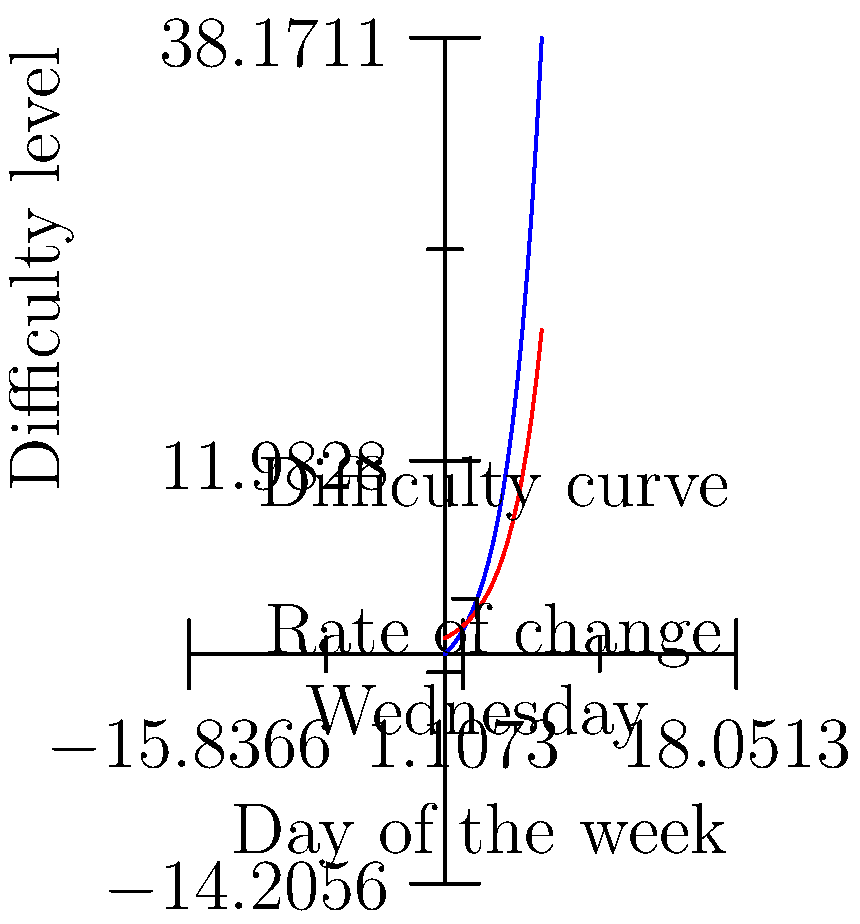As a crossword enthusiast, you've noticed that the difficulty of puzzles tends to increase throughout the week. The blue curve represents the difficulty level, while the red curve shows its rate of change. Given that the difficulty function is $f(x) = 2e^{0.5x} - 2$, where $x$ represents the day of the week (0 for Sunday, 6 for Saturday), what is the rate of change of difficulty on Wednesday (day 3)? To find the rate of change of difficulty on Wednesday, we need to follow these steps:

1. The rate of change is represented by the derivative of the difficulty function.

2. Let's find the derivative of $f(x) = 2e^{0.5x} - 2$:
   $f'(x) = 2 \cdot 0.5 \cdot e^{0.5x} = e^{0.5x}$

3. Now, we need to evaluate this derivative at $x = 3$ (Wednesday):
   $f'(3) = e^{0.5 \cdot 3} = e^{1.5}$

4. Calculate $e^{1.5}$:
   $e^{1.5} \approx 4.4817$

Therefore, the rate of change of difficulty on Wednesday is approximately 4.4817.
Answer: $e^{1.5}$ 